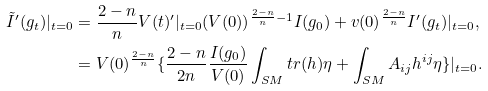Convert formula to latex. <formula><loc_0><loc_0><loc_500><loc_500>\tilde { I } ^ { \prime } ( g _ { t } ) | _ { t = 0 } & = \frac { 2 - n } { n } V ( t ) ^ { \prime } | _ { t = 0 } ( V ( 0 ) ) ^ { \frac { 2 - n } { n } - 1 } I ( g _ { 0 } ) + v ( 0 ) ^ { \frac { 2 - n } { n } } I ^ { \prime } ( g _ { t } ) | _ { t = 0 } , \\ & = V ( 0 ) ^ { \frac { 2 - n } { n } } \{ \frac { 2 - n } { 2 n } \frac { I ( g _ { 0 } ) } { V ( 0 ) } \int _ { S M } t r ( h ) \eta + \int _ { S M } A _ { i j } h ^ { i j } \eta \} | _ { t = 0 } .</formula> 